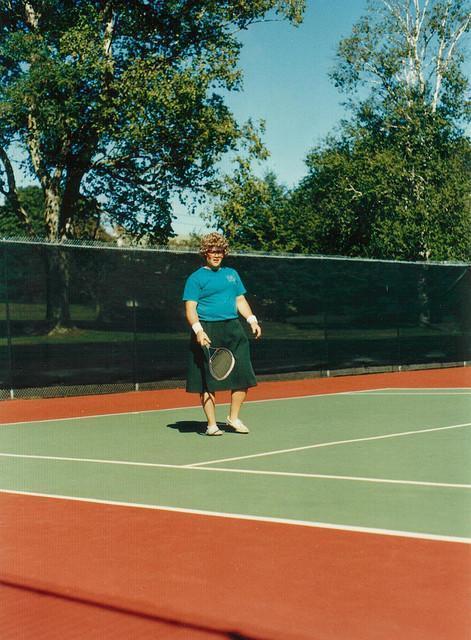How many tennis rackets is this woman holding?
Give a very brief answer. 1. 